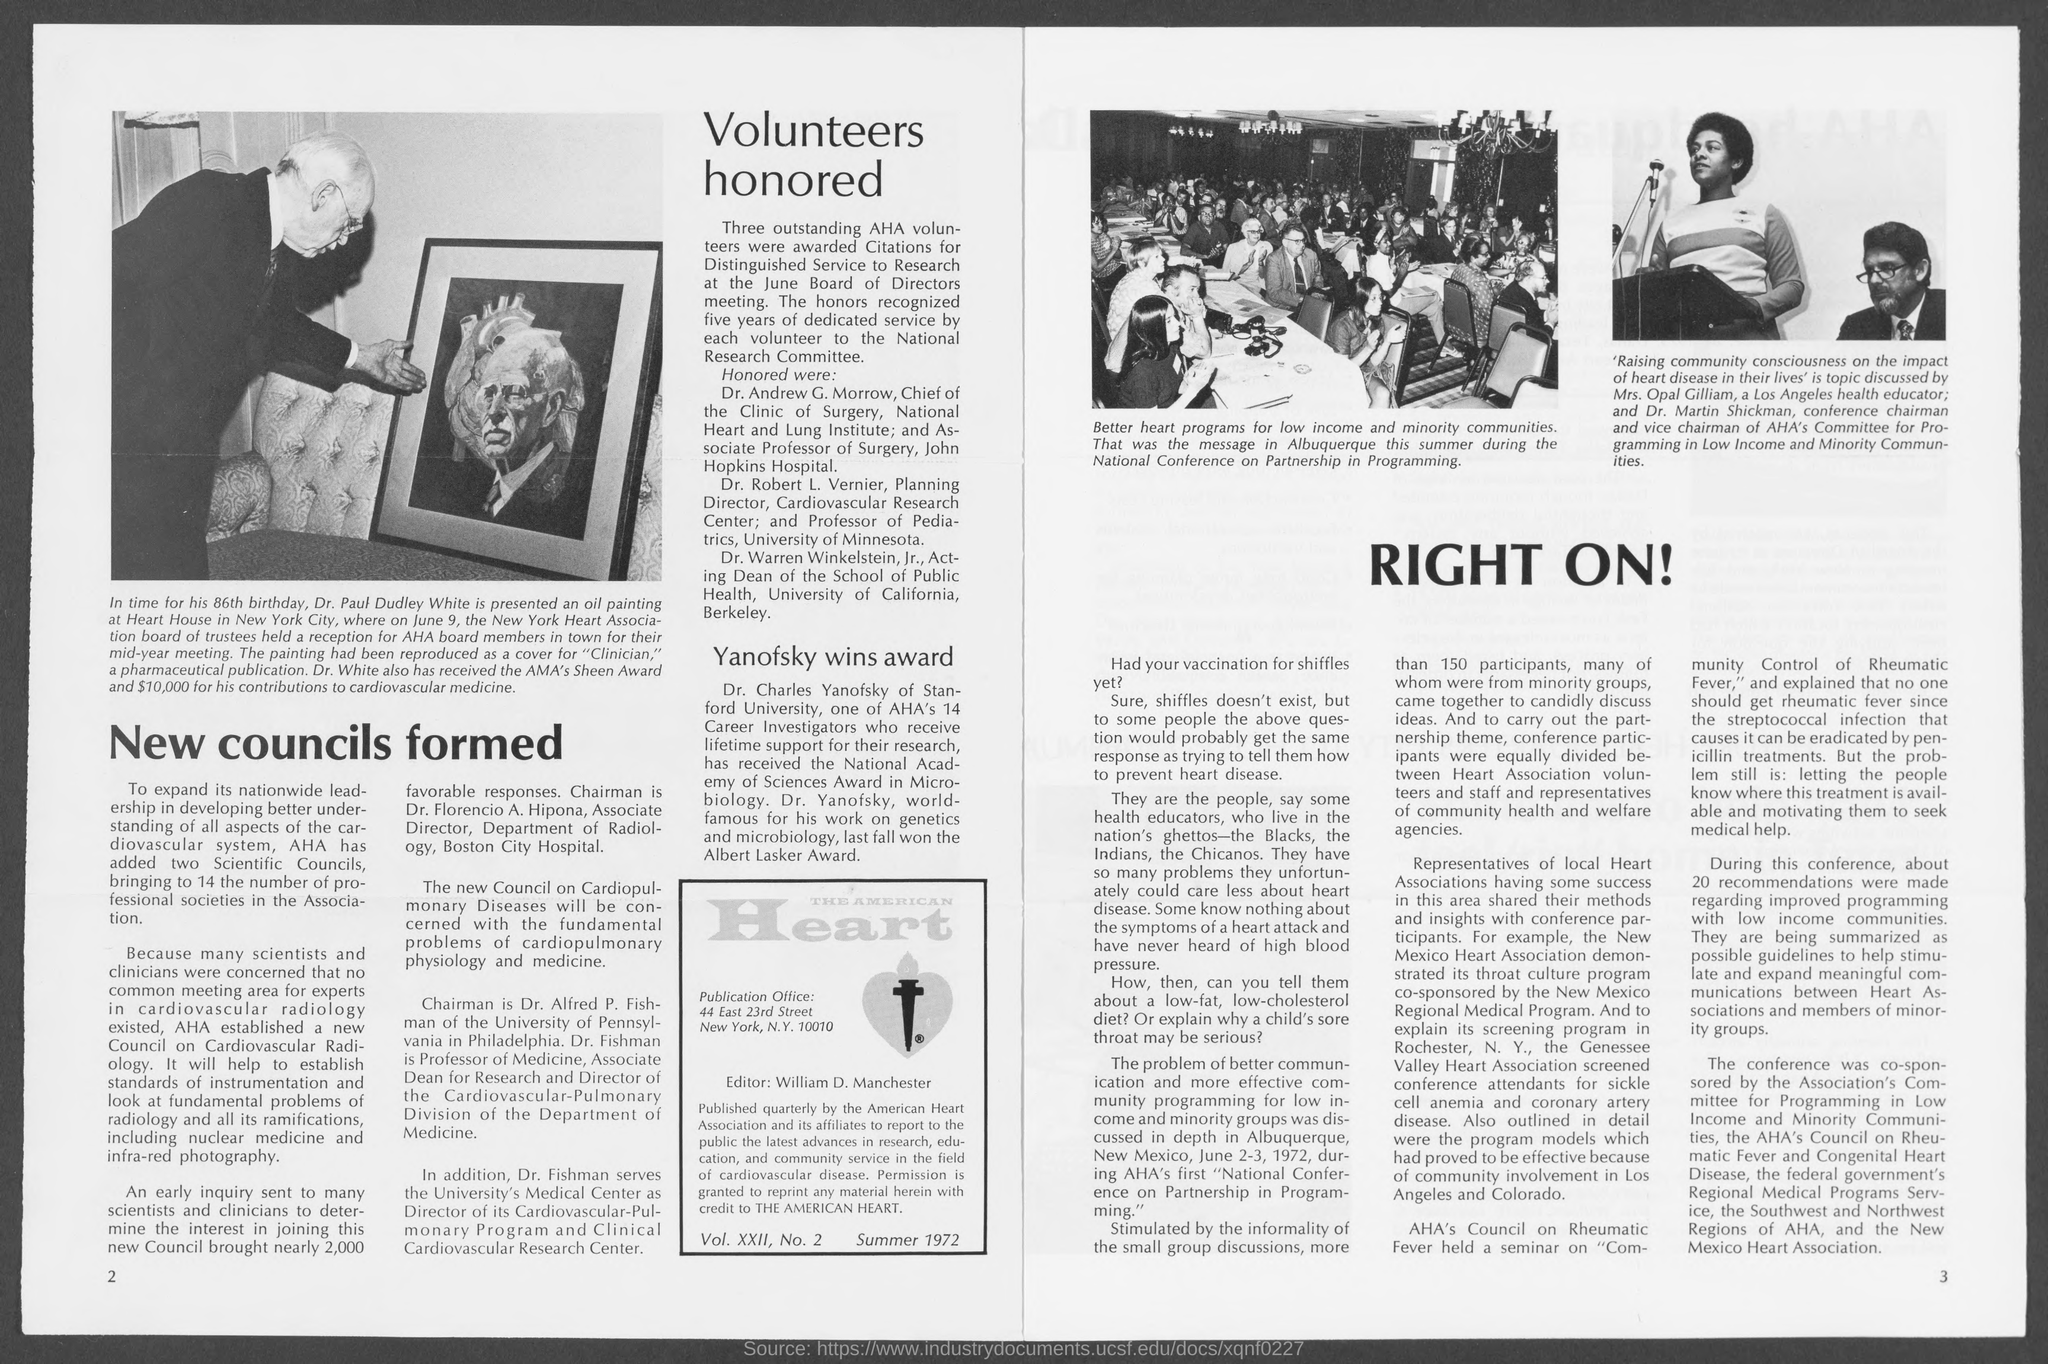Indicate a few pertinent items in this graphic. William D. Manchester is the editor of the American Heart. The number at the bottom-right corner of the page is 3. The publication office is located in New York City. What is the number in the bottom-left corner of the page that is two? 